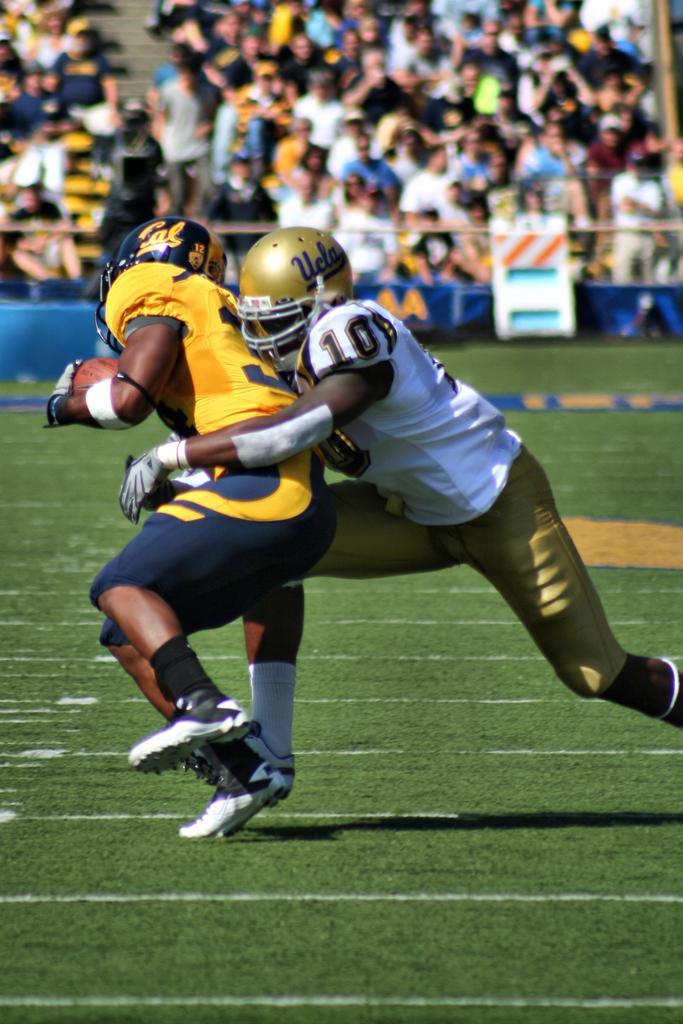How would you summarize this image in a sentence or two? In this image I can see two people on the ground. In the background, I can see some other people. 